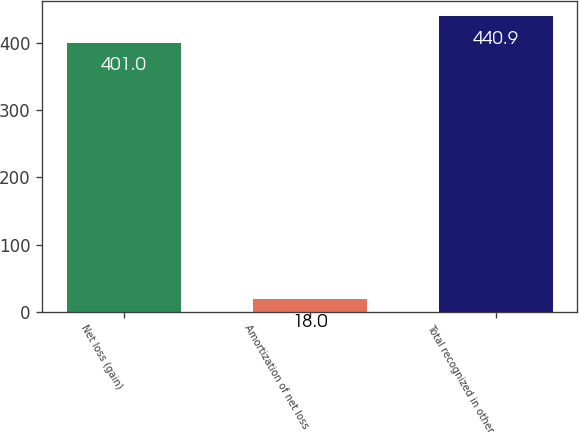Convert chart. <chart><loc_0><loc_0><loc_500><loc_500><bar_chart><fcel>Net loss (gain)<fcel>Amortization of net loss<fcel>Total recognized in other<nl><fcel>401<fcel>18<fcel>440.9<nl></chart> 